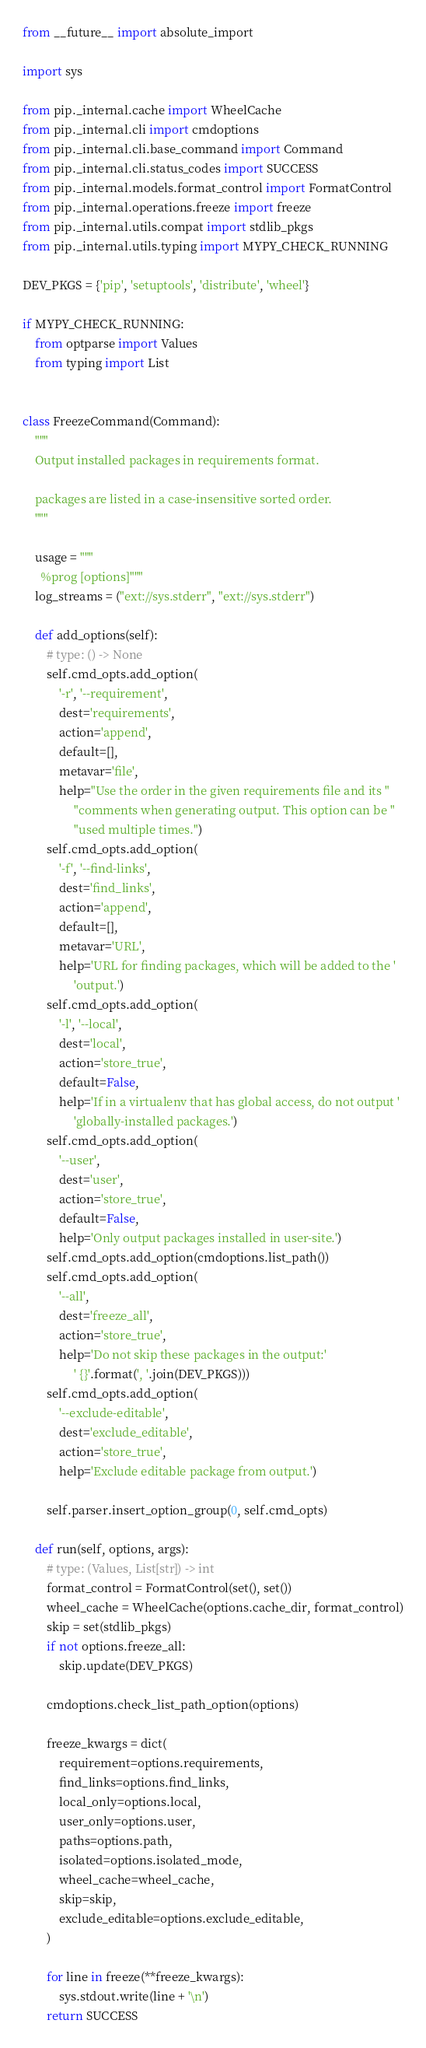Convert code to text. <code><loc_0><loc_0><loc_500><loc_500><_Python_>from __future__ import absolute_import

import sys

from pip._internal.cache import WheelCache
from pip._internal.cli import cmdoptions
from pip._internal.cli.base_command import Command
from pip._internal.cli.status_codes import SUCCESS
from pip._internal.models.format_control import FormatControl
from pip._internal.operations.freeze import freeze
from pip._internal.utils.compat import stdlib_pkgs
from pip._internal.utils.typing import MYPY_CHECK_RUNNING

DEV_PKGS = {'pip', 'setuptools', 'distribute', 'wheel'}

if MYPY_CHECK_RUNNING:
    from optparse import Values
    from typing import List


class FreezeCommand(Command):
    """
    Output installed packages in requirements format.

    packages are listed in a case-insensitive sorted order.
    """

    usage = """
      %prog [options]"""
    log_streams = ("ext://sys.stderr", "ext://sys.stderr")

    def add_options(self):
        # type: () -> None
        self.cmd_opts.add_option(
            '-r', '--requirement',
            dest='requirements',
            action='append',
            default=[],
            metavar='file',
            help="Use the order in the given requirements file and its "
                 "comments when generating output. This option can be "
                 "used multiple times.")
        self.cmd_opts.add_option(
            '-f', '--find-links',
            dest='find_links',
            action='append',
            default=[],
            metavar='URL',
            help='URL for finding packages, which will be added to the '
                 'output.')
        self.cmd_opts.add_option(
            '-l', '--local',
            dest='local',
            action='store_true',
            default=False,
            help='If in a virtualenv that has global access, do not output '
                 'globally-installed packages.')
        self.cmd_opts.add_option(
            '--user',
            dest='user',
            action='store_true',
            default=False,
            help='Only output packages installed in user-site.')
        self.cmd_opts.add_option(cmdoptions.list_path())
        self.cmd_opts.add_option(
            '--all',
            dest='freeze_all',
            action='store_true',
            help='Do not skip these packages in the output:'
                 ' {}'.format(', '.join(DEV_PKGS)))
        self.cmd_opts.add_option(
            '--exclude-editable',
            dest='exclude_editable',
            action='store_true',
            help='Exclude editable package from output.')

        self.parser.insert_option_group(0, self.cmd_opts)

    def run(self, options, args):
        # type: (Values, List[str]) -> int
        format_control = FormatControl(set(), set())
        wheel_cache = WheelCache(options.cache_dir, format_control)
        skip = set(stdlib_pkgs)
        if not options.freeze_all:
            skip.update(DEV_PKGS)

        cmdoptions.check_list_path_option(options)

        freeze_kwargs = dict(
            requirement=options.requirements,
            find_links=options.find_links,
            local_only=options.local,
            user_only=options.user,
            paths=options.path,
            isolated=options.isolated_mode,
            wheel_cache=wheel_cache,
            skip=skip,
            exclude_editable=options.exclude_editable,
        )

        for line in freeze(**freeze_kwargs):
            sys.stdout.write(line + '\n')
        return SUCCESS

</code> 